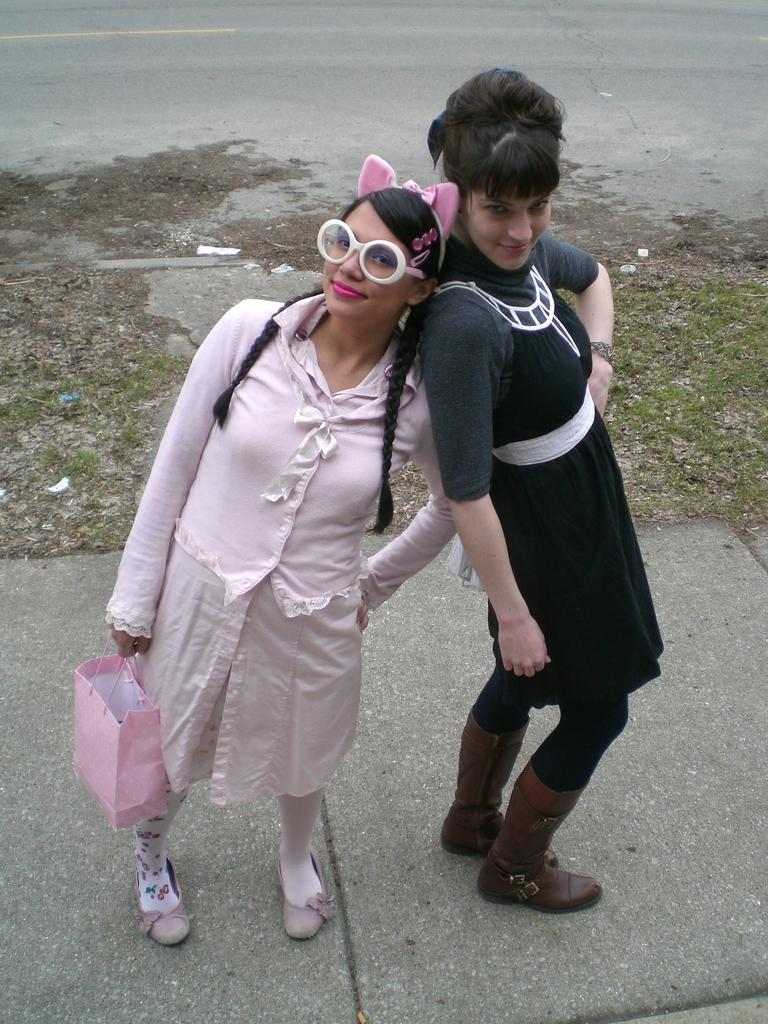How many women are in the image? There are two women in the image. What are the women doing in the image? The women are standing on the ground and smiling. What is one of the women holding? One woman is holding a bag. What can be seen in the background of the image? There is grass and a road visible in the background. Is there a slip visible on the ground in the image? There is no slip present on the ground in the image. 